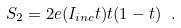Convert formula to latex. <formula><loc_0><loc_0><loc_500><loc_500>S _ { 2 } = 2 e ( I _ { i n c } t ) t ( 1 - t ) \ .</formula> 